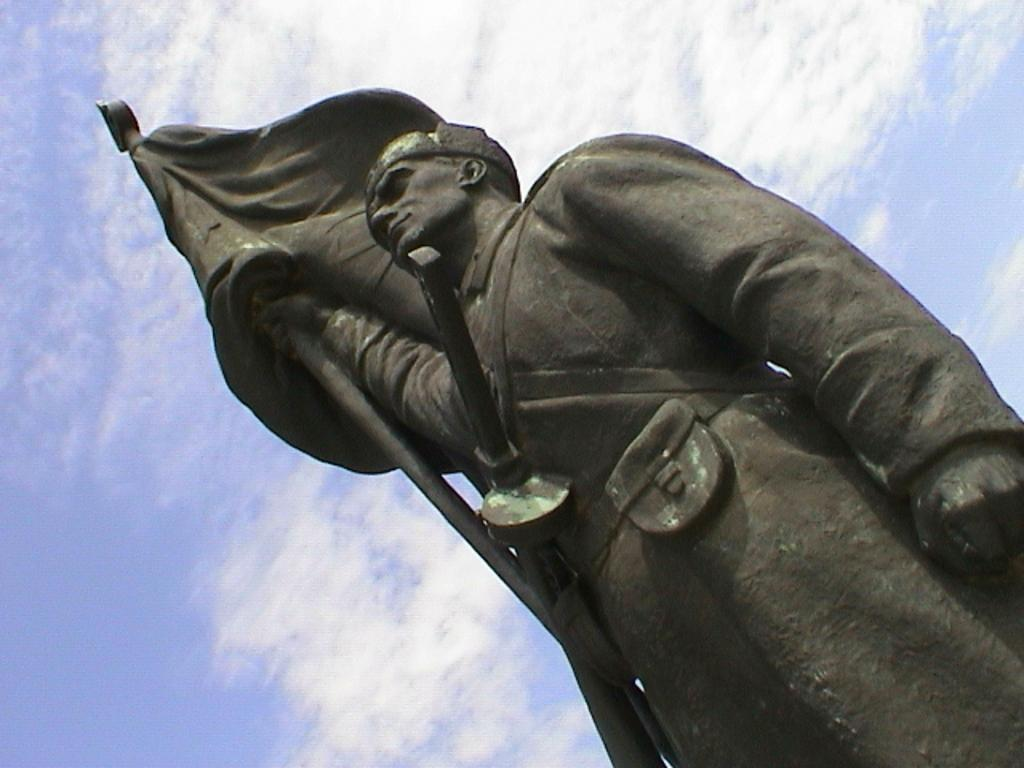What is the main subject of the picture? The main subject of the picture is a statue of a man. What is the man wearing in the picture? The man is wearing a black coat in the picture. What is the man holding in the picture? The man is holding a flag pole in the picture. What is attached to the flag pole? There is a flag in the picture. What is the condition of the sky in the picture? The sky is clear in the picture. Can you tell me how many steam engines are visible in the picture? There are no steam engines present in the image; it features a statue of a man holding a flag pole. What color is the rifle that the man is holding in the picture? There is no rifle present in the picture; the man is holding a flag pole. 